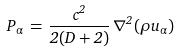<formula> <loc_0><loc_0><loc_500><loc_500>P _ { \alpha } \, = \, \frac { c ^ { 2 } } { 2 ( D + 2 ) } \, \nabla ^ { 2 } ( \rho u _ { \alpha } )</formula> 